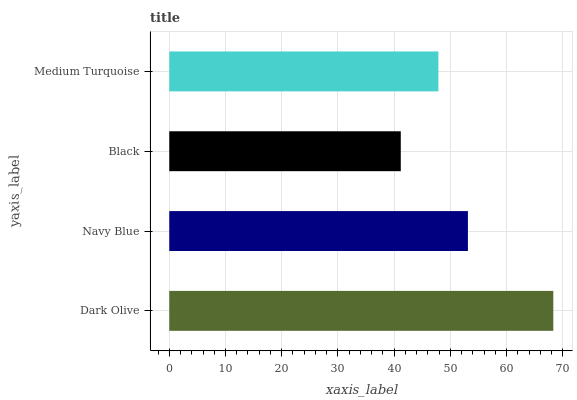Is Black the minimum?
Answer yes or no. Yes. Is Dark Olive the maximum?
Answer yes or no. Yes. Is Navy Blue the minimum?
Answer yes or no. No. Is Navy Blue the maximum?
Answer yes or no. No. Is Dark Olive greater than Navy Blue?
Answer yes or no. Yes. Is Navy Blue less than Dark Olive?
Answer yes or no. Yes. Is Navy Blue greater than Dark Olive?
Answer yes or no. No. Is Dark Olive less than Navy Blue?
Answer yes or no. No. Is Navy Blue the high median?
Answer yes or no. Yes. Is Medium Turquoise the low median?
Answer yes or no. Yes. Is Black the high median?
Answer yes or no. No. Is Black the low median?
Answer yes or no. No. 